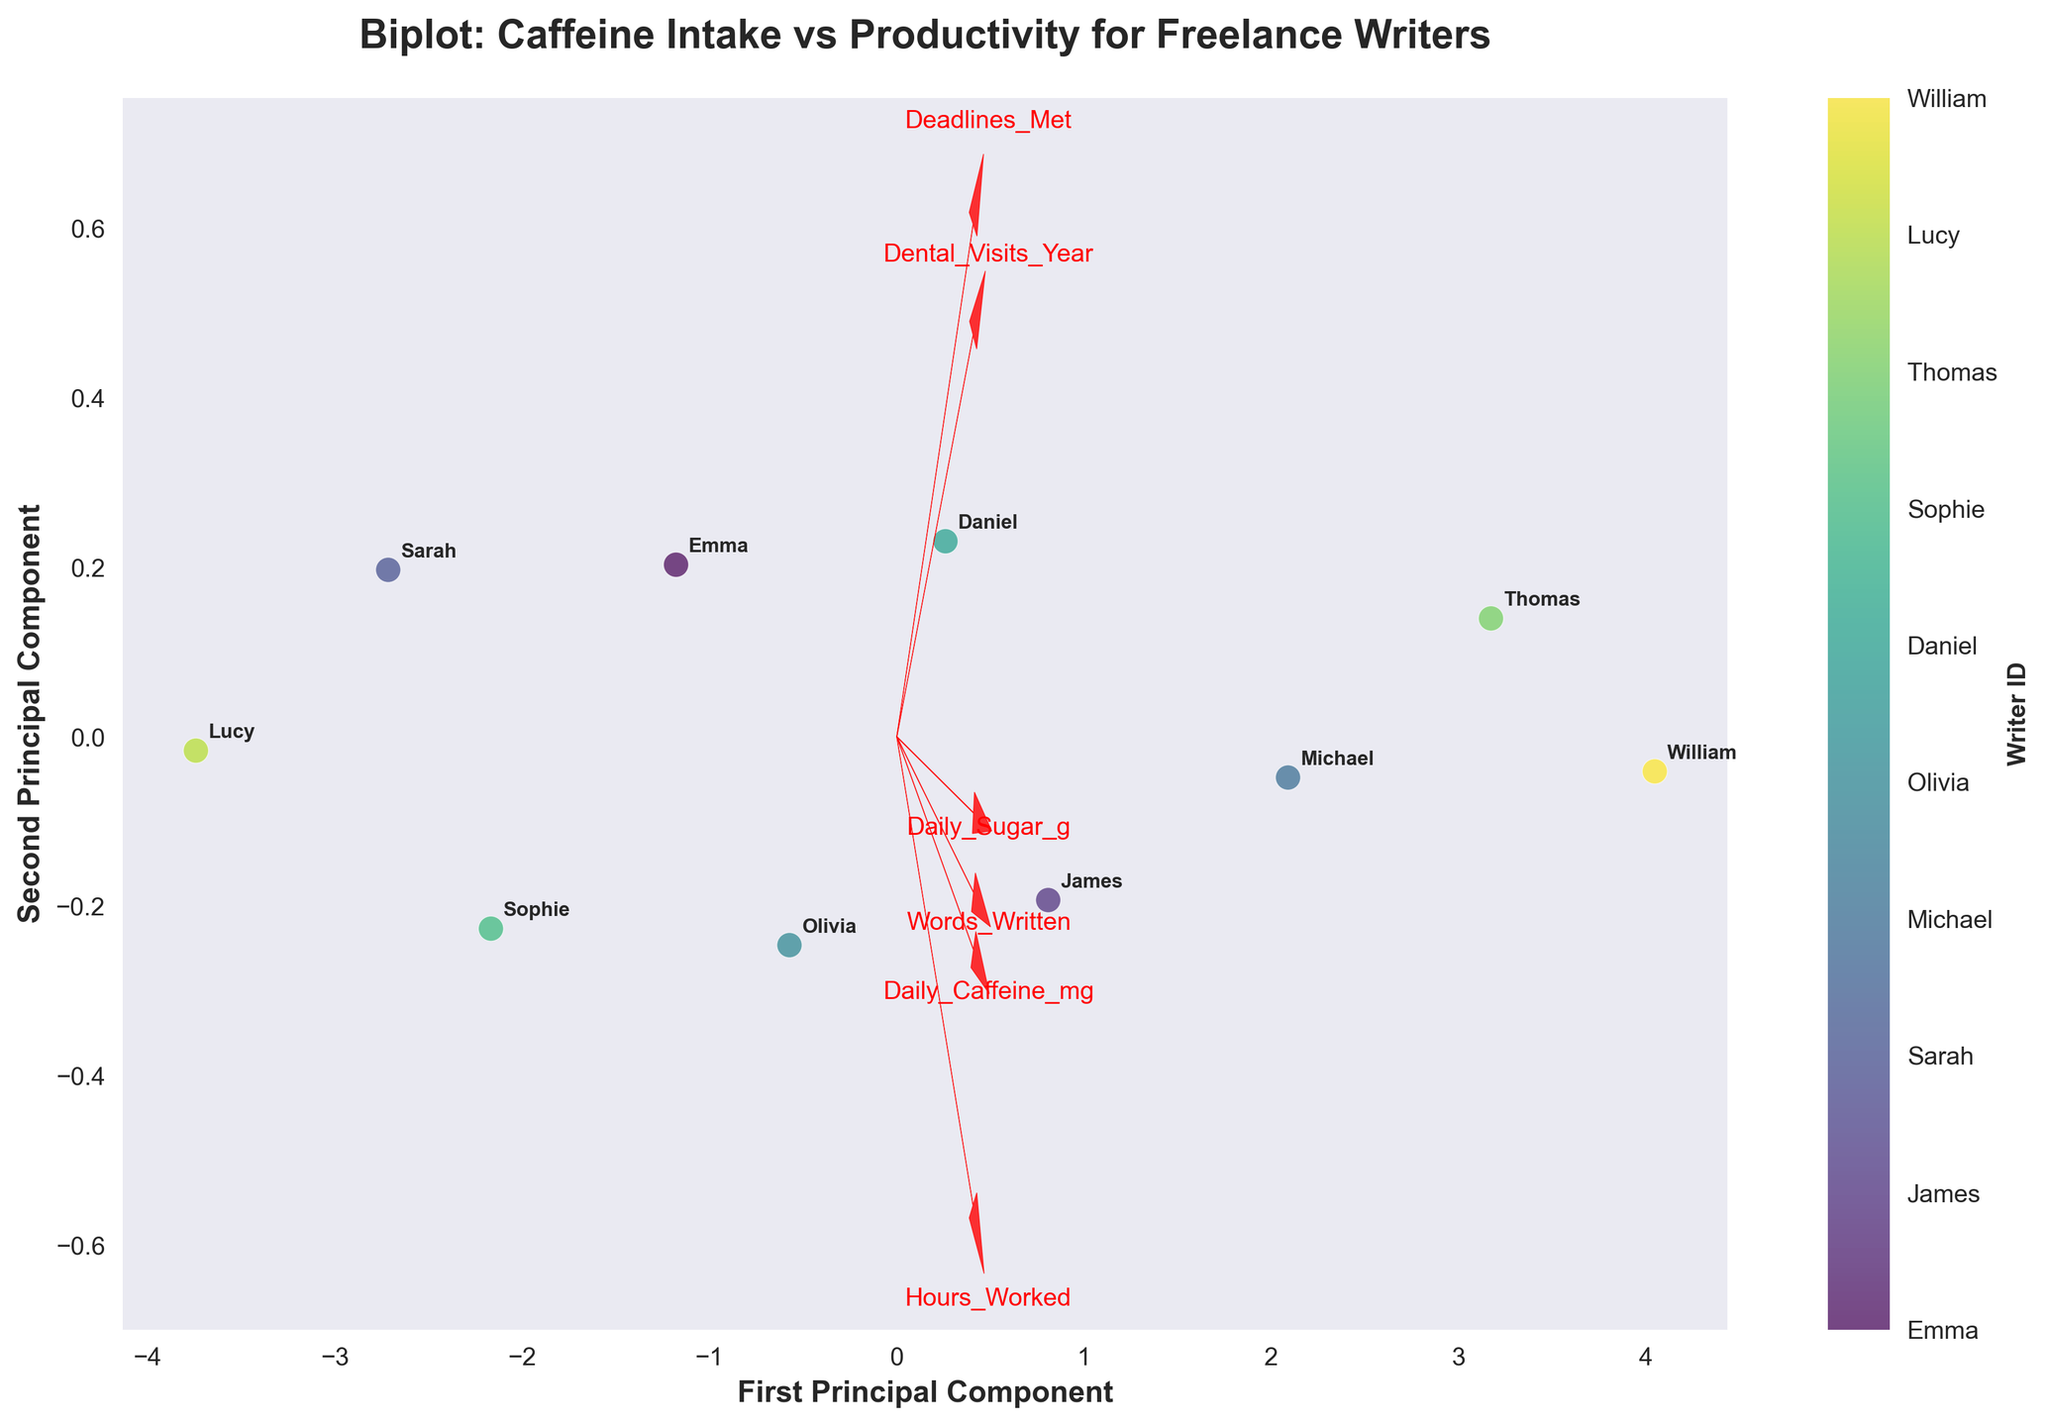Which principal component explains more variance? You can determine which principal component explains more variance by observing the axis labels. If their significance is given, the component with the larger value explains more variance.
Answer: The first principal component How many features are represented in the biplot? The number of feature vectors (arrows) originating from the origin indicates the number of features included in the biplot. Count these vectors.
Answer: 6 Which feature has the longest vector in the biplot? The feature with the longest vector extends furthest from the origin. Check the plot to determine which arrow is longest.
Answer: Words_Written Which writer has the highest position on the first principal component? Observe the data points on the biplot and identify the one furthest along the first principal component (x-axis).
Answer: William How is dental health related to caffeine intake based on the biplot? To assess the relationship, look at the direction and proximity of the 'Dental_Visits_Year' and 'Daily_Caffeine_mg' vectors. If they are close and pointed in the same direction, there might be a positive correlation.
Answer: Positive correlation Compare the productivity of the writer with the least caffeine intake with the writer who consumes the most. Check the productivity feature (Words_Written) relative to the positions of the writers with the least and most caffeine intake (Lucy and William). Note their positions.
Answer: William is more productive than Lucy Is there a strong relation between Daily_Sugar_g and Hours_Worked? Examine the angle between the vectors for 'Daily_Sugar_g' and 'Hours_Worked'. Vectors pointing in similar directions suggest a positive relation, while opposite directions suggest a negative relation.
Answer: Positive relation Which feature appears to have the least impact on the principal components? The feature with the shortest arrow length (smallest vector) indicates the least impact on the principal components.
Answer: Daily_Sugar_g Who is more productive, Olivia or Daniel? Compare their positions relative to the 'Words_Written' vector. The writer closer to (and in the positive direction of) this vector is more productive.
Answer: Daniel Do writers who meet more deadlines consume more caffeine? To determine this, examine the proximity and vectors of 'Deadlines_Met' and 'Daily_Caffeine_mg'. A close and similar direction suggests a positive relation.
Answer: Yes 